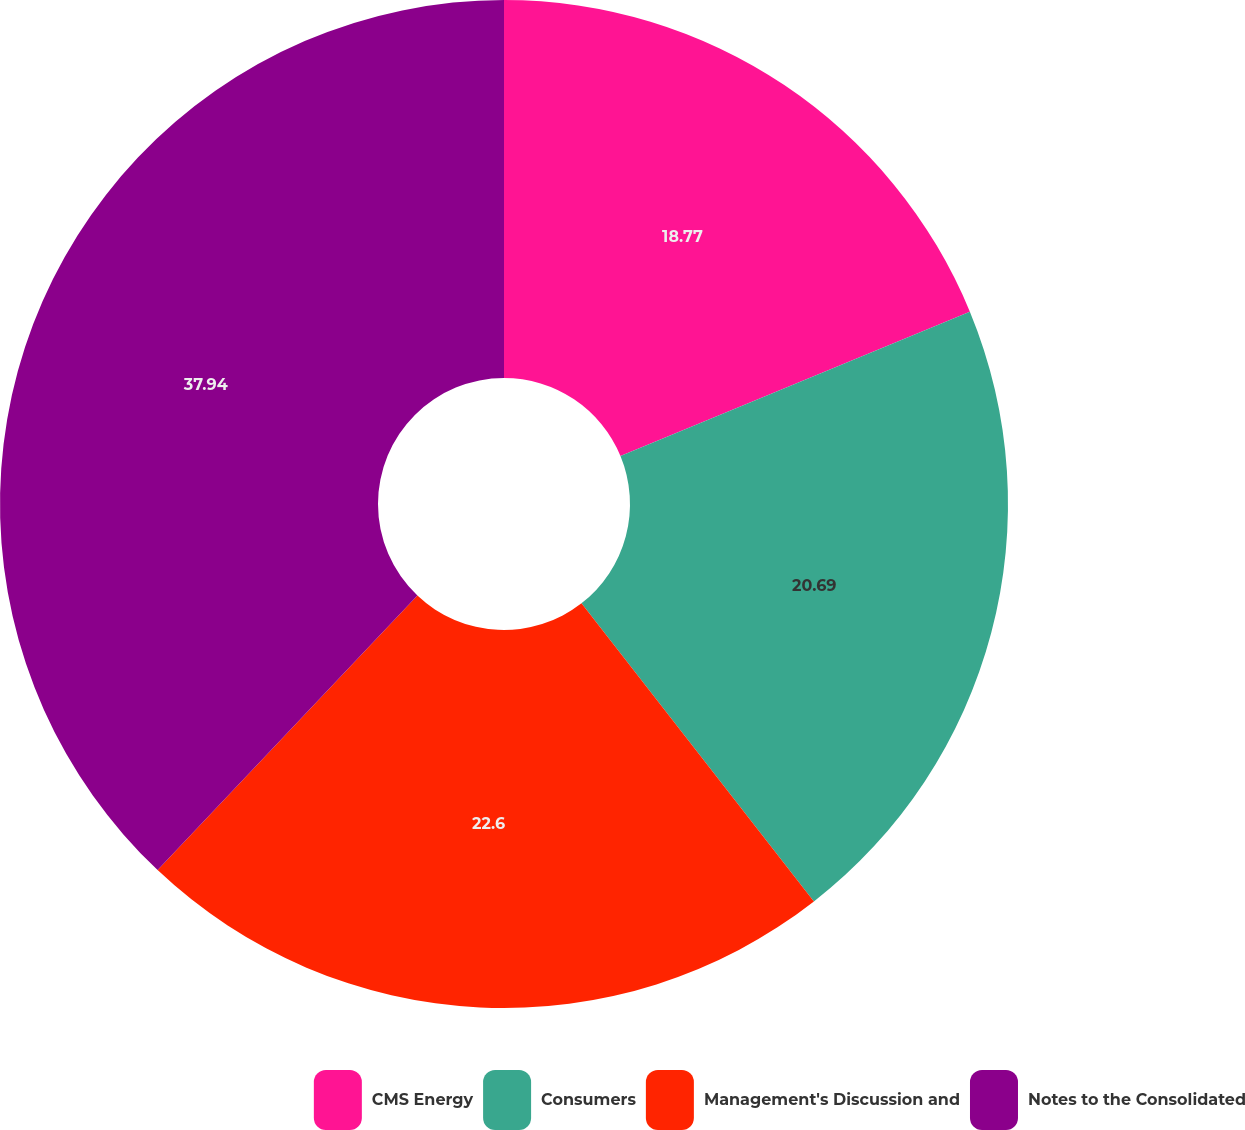Convert chart. <chart><loc_0><loc_0><loc_500><loc_500><pie_chart><fcel>CMS Energy<fcel>Consumers<fcel>Management's Discussion and<fcel>Notes to the Consolidated<nl><fcel>18.77%<fcel>20.69%<fcel>22.6%<fcel>37.94%<nl></chart> 